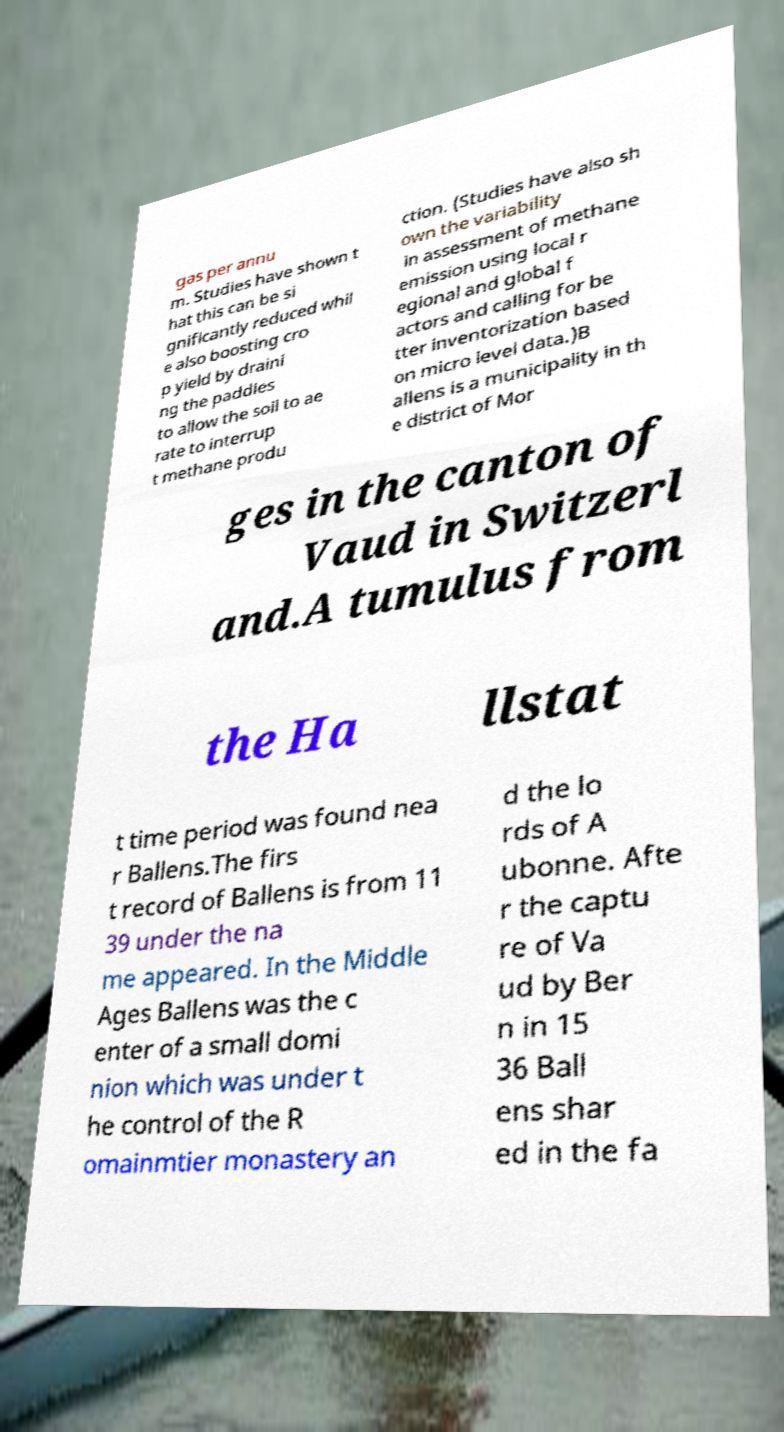What messages or text are displayed in this image? I need them in a readable, typed format. gas per annu m. Studies have shown t hat this can be si gnificantly reduced whil e also boosting cro p yield by draini ng the paddies to allow the soil to ae rate to interrup t methane produ ction. (Studies have also sh own the variability in assessment of methane emission using local r egional and global f actors and calling for be tter inventorization based on micro level data.)B allens is a municipality in th e district of Mor ges in the canton of Vaud in Switzerl and.A tumulus from the Ha llstat t time period was found nea r Ballens.The firs t record of Ballens is from 11 39 under the na me appeared. In the Middle Ages Ballens was the c enter of a small domi nion which was under t he control of the R omainmtier monastery an d the lo rds of A ubonne. Afte r the captu re of Va ud by Ber n in 15 36 Ball ens shar ed in the fa 